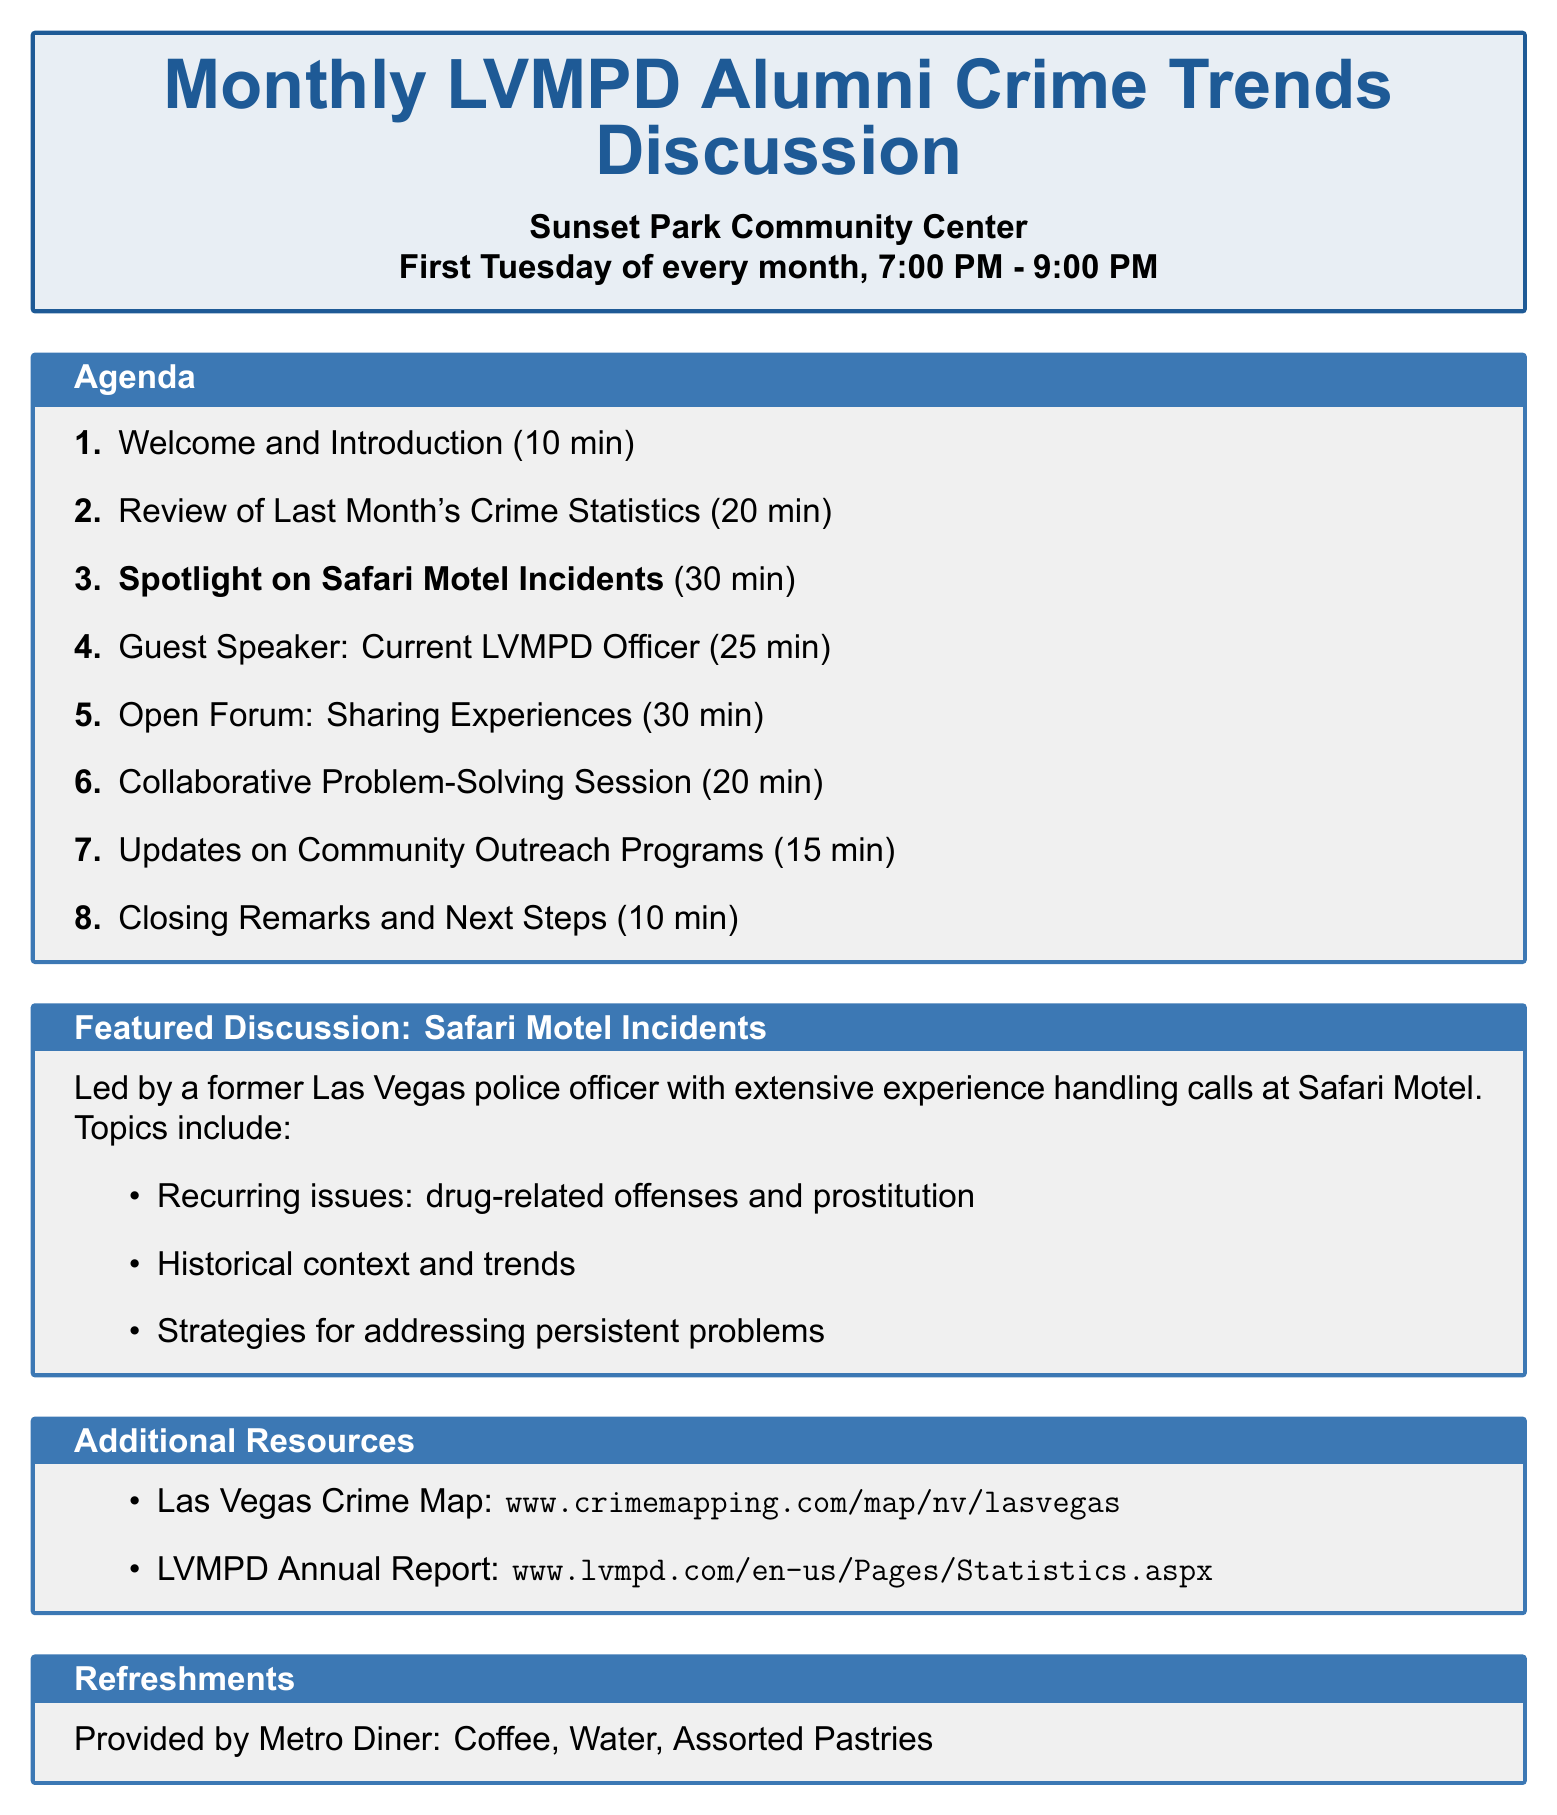What is the title of the meeting? The title of the meeting is stated at the beginning of the document.
Answer: Monthly LVMPD Alumni Crime Trends Discussion Where is the meeting held? The location of the meeting is mentioned right after the title.
Answer: Sunset Park Community Center What time does the meeting start? The starting time of the meeting is specified in the meeting details.
Answer: 7:00 PM How long is the discussion on Safari Motel incidents? The duration for the discussion on Safari Motel is listed in the agenda items.
Answer: 30 minutes Who is the guest speaker? The name of the guest speaker is provided under the agenda items.
Answer: Sergeant Michael Rodriguez What is the focus of the collaborative problem-solving session? The topic of the session is indicated in the agenda description.
Answer: The Fremont Street Experience What is provided by Metro Diner? The document lists refreshments provided by the diner.
Answer: Coffee, Water, Assorted Pastries How many minutes is allocated for closing remarks? The duration for closing remarks is mentioned in the agenda items.
Answer: 10 minutes What is the focus topic for next month? The announcement of next month's focus topic is part of the closing remarks.
Answer: Next month's focus topic 